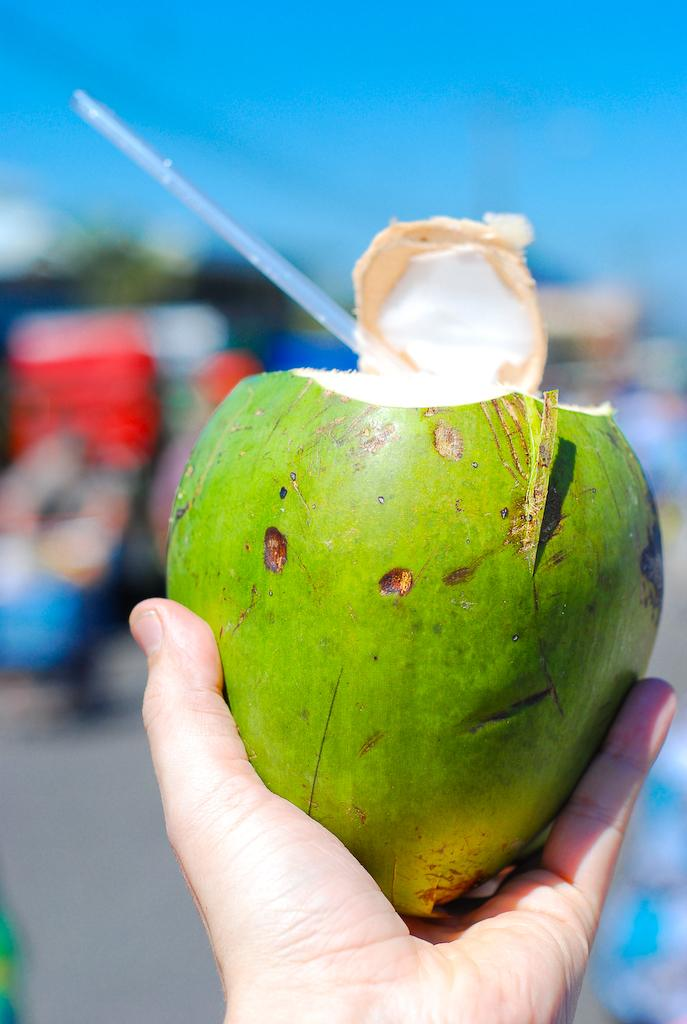What is the hand holding in the image? The hand is holding a coconut in the image. How is the coconut being used? The coconut has a straw on it, suggesting it is being used as a drink. Can you describe the background of the image? The background of the image is blurred. What type of locket is the person wearing in the image? There is no locket present in the image; it only shows a hand holding a coconut with a straw. 